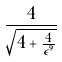<formula> <loc_0><loc_0><loc_500><loc_500>\frac { 4 } { \sqrt { 4 + \frac { 4 } { \epsilon ^ { 9 } } } }</formula> 